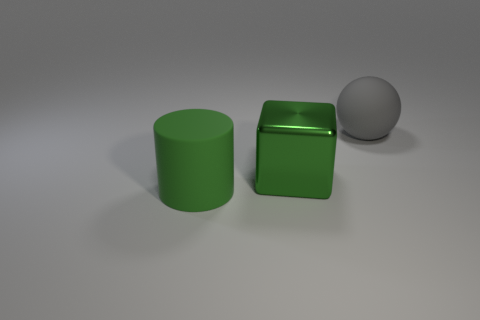Can you describe the possible functions of these objects in a real-world setting? The cylindrical and cubic green objects could serve as containers or stands in a real-world setting, possibly as simplistic designs in a modern decor. The gray ball, due to its common shape, might be part of a larger mechanism or merely a decorative item designed to complement the other objects. 